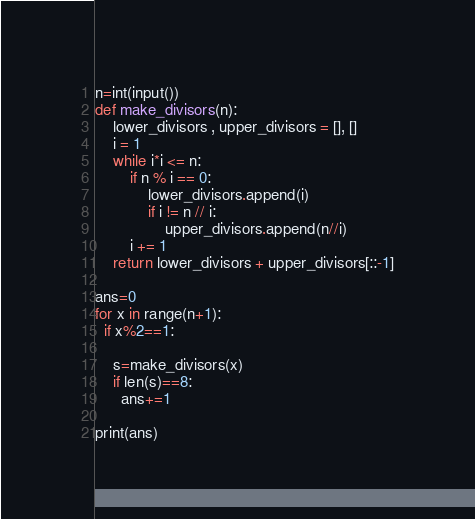Convert code to text. <code><loc_0><loc_0><loc_500><loc_500><_Python_>n=int(input())
def make_divisors(n):
    lower_divisors , upper_divisors = [], []
    i = 1
    while i*i <= n:
        if n % i == 0:
            lower_divisors.append(i)
            if i != n // i:
                upper_divisors.append(n//i)
        i += 1
    return lower_divisors + upper_divisors[::-1]

ans=0
for x in range(n+1):
  if x%2==1:
    
    s=make_divisors(x)
    if len(s)==8:
      ans+=1
    
print(ans)</code> 